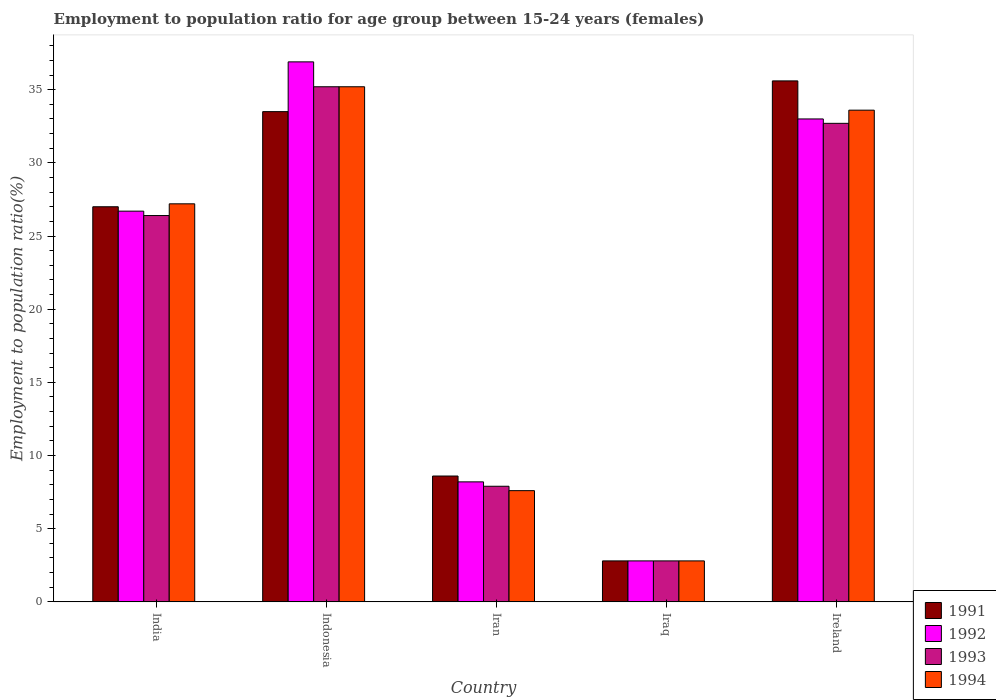How many different coloured bars are there?
Provide a succinct answer. 4. How many groups of bars are there?
Provide a succinct answer. 5. Are the number of bars on each tick of the X-axis equal?
Make the answer very short. Yes. How many bars are there on the 1st tick from the left?
Provide a succinct answer. 4. How many bars are there on the 3rd tick from the right?
Provide a short and direct response. 4. What is the employment to population ratio in 1994 in Ireland?
Your response must be concise. 33.6. Across all countries, what is the maximum employment to population ratio in 1994?
Your response must be concise. 35.2. Across all countries, what is the minimum employment to population ratio in 1993?
Your answer should be very brief. 2.8. In which country was the employment to population ratio in 1991 minimum?
Your answer should be very brief. Iraq. What is the total employment to population ratio in 1994 in the graph?
Give a very brief answer. 106.4. What is the difference between the employment to population ratio in 1993 in Indonesia and that in Iraq?
Offer a very short reply. 32.4. What is the difference between the employment to population ratio in 1993 in India and the employment to population ratio in 1994 in Iraq?
Make the answer very short. 23.6. What is the average employment to population ratio in 1993 per country?
Make the answer very short. 21. What is the difference between the employment to population ratio of/in 1993 and employment to population ratio of/in 1991 in India?
Ensure brevity in your answer.  -0.6. In how many countries, is the employment to population ratio in 1991 greater than 16 %?
Your answer should be compact. 3. What is the ratio of the employment to population ratio in 1991 in Iran to that in Iraq?
Give a very brief answer. 3.07. Is the employment to population ratio in 1992 in Iran less than that in Ireland?
Make the answer very short. Yes. Is the difference between the employment to population ratio in 1993 in Iran and Ireland greater than the difference between the employment to population ratio in 1991 in Iran and Ireland?
Ensure brevity in your answer.  Yes. What is the difference between the highest and the second highest employment to population ratio in 1992?
Ensure brevity in your answer.  6.3. What is the difference between the highest and the lowest employment to population ratio in 1994?
Your answer should be very brief. 32.4. In how many countries, is the employment to population ratio in 1991 greater than the average employment to population ratio in 1991 taken over all countries?
Make the answer very short. 3. Is the sum of the employment to population ratio in 1991 in India and Indonesia greater than the maximum employment to population ratio in 1992 across all countries?
Offer a terse response. Yes. What does the 1st bar from the right in Iraq represents?
Provide a succinct answer. 1994. Is it the case that in every country, the sum of the employment to population ratio in 1992 and employment to population ratio in 1991 is greater than the employment to population ratio in 1993?
Provide a succinct answer. Yes. How many bars are there?
Ensure brevity in your answer.  20. What is the difference between two consecutive major ticks on the Y-axis?
Your answer should be very brief. 5. Does the graph contain any zero values?
Ensure brevity in your answer.  No. What is the title of the graph?
Give a very brief answer. Employment to population ratio for age group between 15-24 years (females). Does "1984" appear as one of the legend labels in the graph?
Your response must be concise. No. What is the label or title of the X-axis?
Give a very brief answer. Country. What is the Employment to population ratio(%) of 1992 in India?
Ensure brevity in your answer.  26.7. What is the Employment to population ratio(%) in 1993 in India?
Your answer should be compact. 26.4. What is the Employment to population ratio(%) in 1994 in India?
Ensure brevity in your answer.  27.2. What is the Employment to population ratio(%) in 1991 in Indonesia?
Make the answer very short. 33.5. What is the Employment to population ratio(%) of 1992 in Indonesia?
Provide a short and direct response. 36.9. What is the Employment to population ratio(%) in 1993 in Indonesia?
Offer a terse response. 35.2. What is the Employment to population ratio(%) in 1994 in Indonesia?
Provide a succinct answer. 35.2. What is the Employment to population ratio(%) in 1991 in Iran?
Ensure brevity in your answer.  8.6. What is the Employment to population ratio(%) in 1992 in Iran?
Your answer should be compact. 8.2. What is the Employment to population ratio(%) of 1993 in Iran?
Ensure brevity in your answer.  7.9. What is the Employment to population ratio(%) of 1994 in Iran?
Offer a very short reply. 7.6. What is the Employment to population ratio(%) of 1991 in Iraq?
Offer a terse response. 2.8. What is the Employment to population ratio(%) in 1992 in Iraq?
Offer a very short reply. 2.8. What is the Employment to population ratio(%) of 1993 in Iraq?
Your response must be concise. 2.8. What is the Employment to population ratio(%) of 1994 in Iraq?
Offer a very short reply. 2.8. What is the Employment to population ratio(%) in 1991 in Ireland?
Offer a terse response. 35.6. What is the Employment to population ratio(%) of 1992 in Ireland?
Offer a terse response. 33. What is the Employment to population ratio(%) of 1993 in Ireland?
Your answer should be very brief. 32.7. What is the Employment to population ratio(%) of 1994 in Ireland?
Provide a short and direct response. 33.6. Across all countries, what is the maximum Employment to population ratio(%) of 1991?
Offer a very short reply. 35.6. Across all countries, what is the maximum Employment to population ratio(%) of 1992?
Your answer should be compact. 36.9. Across all countries, what is the maximum Employment to population ratio(%) in 1993?
Offer a very short reply. 35.2. Across all countries, what is the maximum Employment to population ratio(%) of 1994?
Your answer should be compact. 35.2. Across all countries, what is the minimum Employment to population ratio(%) in 1991?
Give a very brief answer. 2.8. Across all countries, what is the minimum Employment to population ratio(%) of 1992?
Give a very brief answer. 2.8. Across all countries, what is the minimum Employment to population ratio(%) of 1993?
Keep it short and to the point. 2.8. Across all countries, what is the minimum Employment to population ratio(%) in 1994?
Your response must be concise. 2.8. What is the total Employment to population ratio(%) in 1991 in the graph?
Make the answer very short. 107.5. What is the total Employment to population ratio(%) in 1992 in the graph?
Keep it short and to the point. 107.6. What is the total Employment to population ratio(%) of 1993 in the graph?
Your response must be concise. 105. What is the total Employment to population ratio(%) of 1994 in the graph?
Your answer should be very brief. 106.4. What is the difference between the Employment to population ratio(%) in 1991 in India and that in Indonesia?
Your response must be concise. -6.5. What is the difference between the Employment to population ratio(%) in 1992 in India and that in Indonesia?
Your answer should be compact. -10.2. What is the difference between the Employment to population ratio(%) of 1993 in India and that in Indonesia?
Ensure brevity in your answer.  -8.8. What is the difference between the Employment to population ratio(%) in 1991 in India and that in Iran?
Keep it short and to the point. 18.4. What is the difference between the Employment to population ratio(%) of 1994 in India and that in Iran?
Give a very brief answer. 19.6. What is the difference between the Employment to population ratio(%) of 1991 in India and that in Iraq?
Offer a terse response. 24.2. What is the difference between the Employment to population ratio(%) in 1992 in India and that in Iraq?
Give a very brief answer. 23.9. What is the difference between the Employment to population ratio(%) of 1993 in India and that in Iraq?
Offer a very short reply. 23.6. What is the difference between the Employment to population ratio(%) in 1994 in India and that in Iraq?
Offer a very short reply. 24.4. What is the difference between the Employment to population ratio(%) of 1991 in India and that in Ireland?
Give a very brief answer. -8.6. What is the difference between the Employment to population ratio(%) in 1993 in India and that in Ireland?
Your answer should be compact. -6.3. What is the difference between the Employment to population ratio(%) in 1994 in India and that in Ireland?
Offer a very short reply. -6.4. What is the difference between the Employment to population ratio(%) of 1991 in Indonesia and that in Iran?
Your response must be concise. 24.9. What is the difference between the Employment to population ratio(%) in 1992 in Indonesia and that in Iran?
Give a very brief answer. 28.7. What is the difference between the Employment to population ratio(%) in 1993 in Indonesia and that in Iran?
Make the answer very short. 27.3. What is the difference between the Employment to population ratio(%) of 1994 in Indonesia and that in Iran?
Your answer should be very brief. 27.6. What is the difference between the Employment to population ratio(%) of 1991 in Indonesia and that in Iraq?
Your answer should be compact. 30.7. What is the difference between the Employment to population ratio(%) in 1992 in Indonesia and that in Iraq?
Keep it short and to the point. 34.1. What is the difference between the Employment to population ratio(%) in 1993 in Indonesia and that in Iraq?
Make the answer very short. 32.4. What is the difference between the Employment to population ratio(%) of 1994 in Indonesia and that in Iraq?
Keep it short and to the point. 32.4. What is the difference between the Employment to population ratio(%) of 1991 in Indonesia and that in Ireland?
Provide a short and direct response. -2.1. What is the difference between the Employment to population ratio(%) in 1993 in Indonesia and that in Ireland?
Keep it short and to the point. 2.5. What is the difference between the Employment to population ratio(%) in 1991 in Iran and that in Iraq?
Provide a succinct answer. 5.8. What is the difference between the Employment to population ratio(%) in 1992 in Iran and that in Iraq?
Provide a short and direct response. 5.4. What is the difference between the Employment to population ratio(%) of 1993 in Iran and that in Iraq?
Provide a succinct answer. 5.1. What is the difference between the Employment to population ratio(%) in 1994 in Iran and that in Iraq?
Make the answer very short. 4.8. What is the difference between the Employment to population ratio(%) of 1991 in Iran and that in Ireland?
Offer a terse response. -27. What is the difference between the Employment to population ratio(%) in 1992 in Iran and that in Ireland?
Your response must be concise. -24.8. What is the difference between the Employment to population ratio(%) of 1993 in Iran and that in Ireland?
Your answer should be very brief. -24.8. What is the difference between the Employment to population ratio(%) in 1991 in Iraq and that in Ireland?
Your answer should be compact. -32.8. What is the difference between the Employment to population ratio(%) in 1992 in Iraq and that in Ireland?
Offer a terse response. -30.2. What is the difference between the Employment to population ratio(%) in 1993 in Iraq and that in Ireland?
Your answer should be very brief. -29.9. What is the difference between the Employment to population ratio(%) in 1994 in Iraq and that in Ireland?
Give a very brief answer. -30.8. What is the difference between the Employment to population ratio(%) of 1991 in India and the Employment to population ratio(%) of 1992 in Indonesia?
Offer a terse response. -9.9. What is the difference between the Employment to population ratio(%) of 1992 in India and the Employment to population ratio(%) of 1993 in Indonesia?
Offer a terse response. -8.5. What is the difference between the Employment to population ratio(%) of 1991 in India and the Employment to population ratio(%) of 1994 in Iran?
Offer a terse response. 19.4. What is the difference between the Employment to population ratio(%) of 1991 in India and the Employment to population ratio(%) of 1992 in Iraq?
Give a very brief answer. 24.2. What is the difference between the Employment to population ratio(%) in 1991 in India and the Employment to population ratio(%) in 1993 in Iraq?
Your answer should be very brief. 24.2. What is the difference between the Employment to population ratio(%) of 1991 in India and the Employment to population ratio(%) of 1994 in Iraq?
Your answer should be compact. 24.2. What is the difference between the Employment to population ratio(%) in 1992 in India and the Employment to population ratio(%) in 1993 in Iraq?
Offer a very short reply. 23.9. What is the difference between the Employment to population ratio(%) of 1992 in India and the Employment to population ratio(%) of 1994 in Iraq?
Offer a very short reply. 23.9. What is the difference between the Employment to population ratio(%) in 1993 in India and the Employment to population ratio(%) in 1994 in Iraq?
Offer a very short reply. 23.6. What is the difference between the Employment to population ratio(%) in 1991 in India and the Employment to population ratio(%) in 1992 in Ireland?
Your response must be concise. -6. What is the difference between the Employment to population ratio(%) of 1991 in India and the Employment to population ratio(%) of 1993 in Ireland?
Make the answer very short. -5.7. What is the difference between the Employment to population ratio(%) in 1992 in India and the Employment to population ratio(%) in 1994 in Ireland?
Provide a short and direct response. -6.9. What is the difference between the Employment to population ratio(%) in 1993 in India and the Employment to population ratio(%) in 1994 in Ireland?
Your response must be concise. -7.2. What is the difference between the Employment to population ratio(%) in 1991 in Indonesia and the Employment to population ratio(%) in 1992 in Iran?
Offer a very short reply. 25.3. What is the difference between the Employment to population ratio(%) of 1991 in Indonesia and the Employment to population ratio(%) of 1993 in Iran?
Your answer should be compact. 25.6. What is the difference between the Employment to population ratio(%) in 1991 in Indonesia and the Employment to population ratio(%) in 1994 in Iran?
Your response must be concise. 25.9. What is the difference between the Employment to population ratio(%) in 1992 in Indonesia and the Employment to population ratio(%) in 1994 in Iran?
Make the answer very short. 29.3. What is the difference between the Employment to population ratio(%) of 1993 in Indonesia and the Employment to population ratio(%) of 1994 in Iran?
Provide a short and direct response. 27.6. What is the difference between the Employment to population ratio(%) of 1991 in Indonesia and the Employment to population ratio(%) of 1992 in Iraq?
Ensure brevity in your answer.  30.7. What is the difference between the Employment to population ratio(%) of 1991 in Indonesia and the Employment to population ratio(%) of 1993 in Iraq?
Your response must be concise. 30.7. What is the difference between the Employment to population ratio(%) in 1991 in Indonesia and the Employment to population ratio(%) in 1994 in Iraq?
Your answer should be very brief. 30.7. What is the difference between the Employment to population ratio(%) in 1992 in Indonesia and the Employment to population ratio(%) in 1993 in Iraq?
Make the answer very short. 34.1. What is the difference between the Employment to population ratio(%) in 1992 in Indonesia and the Employment to population ratio(%) in 1994 in Iraq?
Provide a succinct answer. 34.1. What is the difference between the Employment to population ratio(%) of 1993 in Indonesia and the Employment to population ratio(%) of 1994 in Iraq?
Your answer should be very brief. 32.4. What is the difference between the Employment to population ratio(%) in 1991 in Indonesia and the Employment to population ratio(%) in 1992 in Ireland?
Your response must be concise. 0.5. What is the difference between the Employment to population ratio(%) in 1992 in Indonesia and the Employment to population ratio(%) in 1994 in Ireland?
Offer a terse response. 3.3. What is the difference between the Employment to population ratio(%) of 1993 in Indonesia and the Employment to population ratio(%) of 1994 in Ireland?
Make the answer very short. 1.6. What is the difference between the Employment to population ratio(%) in 1991 in Iran and the Employment to population ratio(%) in 1994 in Iraq?
Provide a succinct answer. 5.8. What is the difference between the Employment to population ratio(%) in 1992 in Iran and the Employment to population ratio(%) in 1994 in Iraq?
Provide a short and direct response. 5.4. What is the difference between the Employment to population ratio(%) of 1993 in Iran and the Employment to population ratio(%) of 1994 in Iraq?
Your answer should be very brief. 5.1. What is the difference between the Employment to population ratio(%) of 1991 in Iran and the Employment to population ratio(%) of 1992 in Ireland?
Keep it short and to the point. -24.4. What is the difference between the Employment to population ratio(%) of 1991 in Iran and the Employment to population ratio(%) of 1993 in Ireland?
Your answer should be compact. -24.1. What is the difference between the Employment to population ratio(%) in 1991 in Iran and the Employment to population ratio(%) in 1994 in Ireland?
Offer a terse response. -25. What is the difference between the Employment to population ratio(%) of 1992 in Iran and the Employment to population ratio(%) of 1993 in Ireland?
Give a very brief answer. -24.5. What is the difference between the Employment to population ratio(%) in 1992 in Iran and the Employment to population ratio(%) in 1994 in Ireland?
Your response must be concise. -25.4. What is the difference between the Employment to population ratio(%) in 1993 in Iran and the Employment to population ratio(%) in 1994 in Ireland?
Offer a very short reply. -25.7. What is the difference between the Employment to population ratio(%) of 1991 in Iraq and the Employment to population ratio(%) of 1992 in Ireland?
Provide a short and direct response. -30.2. What is the difference between the Employment to population ratio(%) of 1991 in Iraq and the Employment to population ratio(%) of 1993 in Ireland?
Give a very brief answer. -29.9. What is the difference between the Employment to population ratio(%) in 1991 in Iraq and the Employment to population ratio(%) in 1994 in Ireland?
Your answer should be compact. -30.8. What is the difference between the Employment to population ratio(%) in 1992 in Iraq and the Employment to population ratio(%) in 1993 in Ireland?
Provide a succinct answer. -29.9. What is the difference between the Employment to population ratio(%) of 1992 in Iraq and the Employment to population ratio(%) of 1994 in Ireland?
Make the answer very short. -30.8. What is the difference between the Employment to population ratio(%) in 1993 in Iraq and the Employment to population ratio(%) in 1994 in Ireland?
Ensure brevity in your answer.  -30.8. What is the average Employment to population ratio(%) of 1992 per country?
Your response must be concise. 21.52. What is the average Employment to population ratio(%) in 1994 per country?
Offer a terse response. 21.28. What is the difference between the Employment to population ratio(%) of 1991 and Employment to population ratio(%) of 1993 in India?
Keep it short and to the point. 0.6. What is the difference between the Employment to population ratio(%) of 1992 and Employment to population ratio(%) of 1994 in India?
Offer a terse response. -0.5. What is the difference between the Employment to population ratio(%) in 1991 and Employment to population ratio(%) in 1993 in Indonesia?
Your answer should be very brief. -1.7. What is the difference between the Employment to population ratio(%) in 1991 and Employment to population ratio(%) in 1994 in Indonesia?
Offer a very short reply. -1.7. What is the difference between the Employment to population ratio(%) of 1991 and Employment to population ratio(%) of 1992 in Iran?
Offer a terse response. 0.4. What is the difference between the Employment to population ratio(%) of 1991 and Employment to population ratio(%) of 1993 in Iran?
Provide a short and direct response. 0.7. What is the difference between the Employment to population ratio(%) in 1991 and Employment to population ratio(%) in 1994 in Iran?
Offer a very short reply. 1. What is the difference between the Employment to population ratio(%) in 1992 and Employment to population ratio(%) in 1993 in Iran?
Your response must be concise. 0.3. What is the difference between the Employment to population ratio(%) of 1992 and Employment to population ratio(%) of 1994 in Iran?
Give a very brief answer. 0.6. What is the difference between the Employment to population ratio(%) in 1991 and Employment to population ratio(%) in 1992 in Iraq?
Offer a terse response. 0. What is the difference between the Employment to population ratio(%) of 1991 and Employment to population ratio(%) of 1993 in Iraq?
Your answer should be very brief. 0. What is the difference between the Employment to population ratio(%) in 1992 and Employment to population ratio(%) in 1993 in Iraq?
Offer a very short reply. 0. What is the difference between the Employment to population ratio(%) in 1991 and Employment to population ratio(%) in 1992 in Ireland?
Offer a terse response. 2.6. What is the difference between the Employment to population ratio(%) in 1991 and Employment to population ratio(%) in 1993 in Ireland?
Your answer should be compact. 2.9. What is the difference between the Employment to population ratio(%) of 1992 and Employment to population ratio(%) of 1994 in Ireland?
Provide a short and direct response. -0.6. What is the difference between the Employment to population ratio(%) in 1993 and Employment to population ratio(%) in 1994 in Ireland?
Offer a terse response. -0.9. What is the ratio of the Employment to population ratio(%) in 1991 in India to that in Indonesia?
Give a very brief answer. 0.81. What is the ratio of the Employment to population ratio(%) in 1992 in India to that in Indonesia?
Give a very brief answer. 0.72. What is the ratio of the Employment to population ratio(%) in 1994 in India to that in Indonesia?
Offer a very short reply. 0.77. What is the ratio of the Employment to population ratio(%) in 1991 in India to that in Iran?
Ensure brevity in your answer.  3.14. What is the ratio of the Employment to population ratio(%) in 1992 in India to that in Iran?
Provide a short and direct response. 3.26. What is the ratio of the Employment to population ratio(%) of 1993 in India to that in Iran?
Make the answer very short. 3.34. What is the ratio of the Employment to population ratio(%) of 1994 in India to that in Iran?
Provide a short and direct response. 3.58. What is the ratio of the Employment to population ratio(%) in 1991 in India to that in Iraq?
Ensure brevity in your answer.  9.64. What is the ratio of the Employment to population ratio(%) in 1992 in India to that in Iraq?
Offer a terse response. 9.54. What is the ratio of the Employment to population ratio(%) of 1993 in India to that in Iraq?
Offer a very short reply. 9.43. What is the ratio of the Employment to population ratio(%) of 1994 in India to that in Iraq?
Ensure brevity in your answer.  9.71. What is the ratio of the Employment to population ratio(%) in 1991 in India to that in Ireland?
Offer a very short reply. 0.76. What is the ratio of the Employment to population ratio(%) of 1992 in India to that in Ireland?
Offer a terse response. 0.81. What is the ratio of the Employment to population ratio(%) in 1993 in India to that in Ireland?
Ensure brevity in your answer.  0.81. What is the ratio of the Employment to population ratio(%) in 1994 in India to that in Ireland?
Give a very brief answer. 0.81. What is the ratio of the Employment to population ratio(%) of 1991 in Indonesia to that in Iran?
Your answer should be very brief. 3.9. What is the ratio of the Employment to population ratio(%) of 1992 in Indonesia to that in Iran?
Offer a very short reply. 4.5. What is the ratio of the Employment to population ratio(%) in 1993 in Indonesia to that in Iran?
Offer a very short reply. 4.46. What is the ratio of the Employment to population ratio(%) of 1994 in Indonesia to that in Iran?
Your response must be concise. 4.63. What is the ratio of the Employment to population ratio(%) of 1991 in Indonesia to that in Iraq?
Make the answer very short. 11.96. What is the ratio of the Employment to population ratio(%) in 1992 in Indonesia to that in Iraq?
Your response must be concise. 13.18. What is the ratio of the Employment to population ratio(%) of 1993 in Indonesia to that in Iraq?
Offer a terse response. 12.57. What is the ratio of the Employment to population ratio(%) of 1994 in Indonesia to that in Iraq?
Give a very brief answer. 12.57. What is the ratio of the Employment to population ratio(%) of 1991 in Indonesia to that in Ireland?
Ensure brevity in your answer.  0.94. What is the ratio of the Employment to population ratio(%) of 1992 in Indonesia to that in Ireland?
Make the answer very short. 1.12. What is the ratio of the Employment to population ratio(%) of 1993 in Indonesia to that in Ireland?
Your response must be concise. 1.08. What is the ratio of the Employment to population ratio(%) in 1994 in Indonesia to that in Ireland?
Give a very brief answer. 1.05. What is the ratio of the Employment to population ratio(%) of 1991 in Iran to that in Iraq?
Your response must be concise. 3.07. What is the ratio of the Employment to population ratio(%) in 1992 in Iran to that in Iraq?
Your response must be concise. 2.93. What is the ratio of the Employment to population ratio(%) of 1993 in Iran to that in Iraq?
Make the answer very short. 2.82. What is the ratio of the Employment to population ratio(%) of 1994 in Iran to that in Iraq?
Your answer should be very brief. 2.71. What is the ratio of the Employment to population ratio(%) in 1991 in Iran to that in Ireland?
Provide a succinct answer. 0.24. What is the ratio of the Employment to population ratio(%) of 1992 in Iran to that in Ireland?
Provide a short and direct response. 0.25. What is the ratio of the Employment to population ratio(%) in 1993 in Iran to that in Ireland?
Offer a very short reply. 0.24. What is the ratio of the Employment to population ratio(%) in 1994 in Iran to that in Ireland?
Offer a very short reply. 0.23. What is the ratio of the Employment to population ratio(%) in 1991 in Iraq to that in Ireland?
Your answer should be very brief. 0.08. What is the ratio of the Employment to population ratio(%) of 1992 in Iraq to that in Ireland?
Your answer should be compact. 0.08. What is the ratio of the Employment to population ratio(%) of 1993 in Iraq to that in Ireland?
Keep it short and to the point. 0.09. What is the ratio of the Employment to population ratio(%) in 1994 in Iraq to that in Ireland?
Give a very brief answer. 0.08. What is the difference between the highest and the second highest Employment to population ratio(%) of 1992?
Ensure brevity in your answer.  3.9. What is the difference between the highest and the lowest Employment to population ratio(%) of 1991?
Offer a very short reply. 32.8. What is the difference between the highest and the lowest Employment to population ratio(%) in 1992?
Ensure brevity in your answer.  34.1. What is the difference between the highest and the lowest Employment to population ratio(%) in 1993?
Make the answer very short. 32.4. What is the difference between the highest and the lowest Employment to population ratio(%) in 1994?
Offer a terse response. 32.4. 